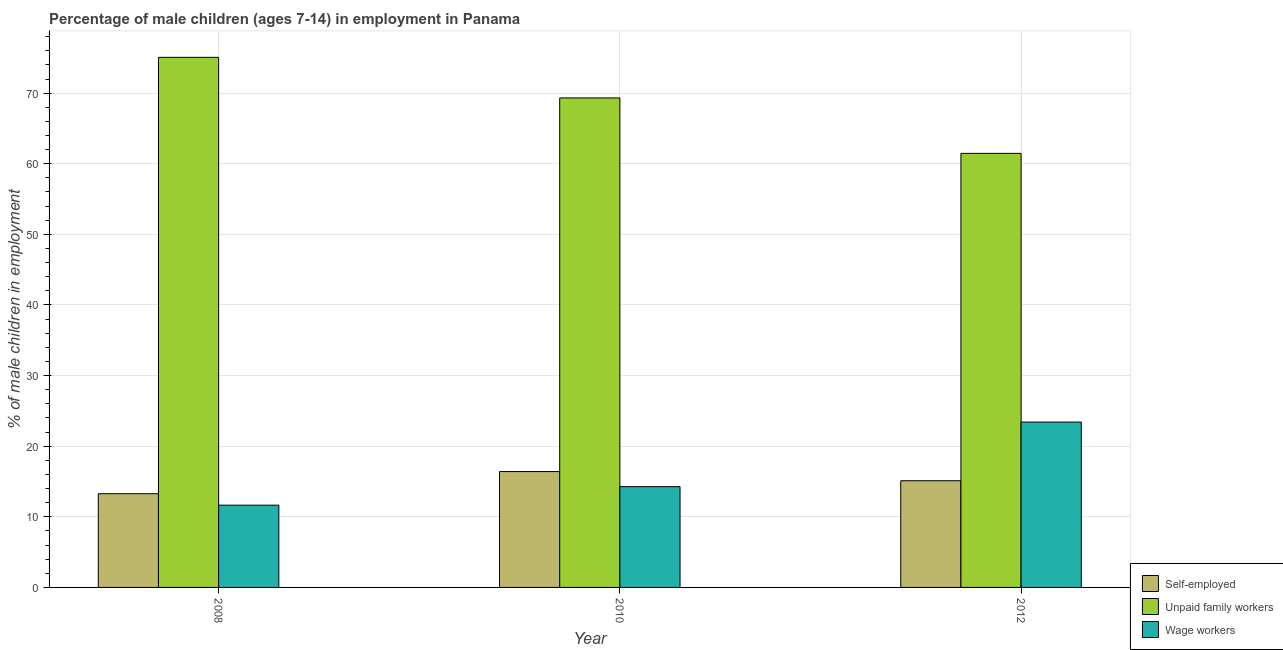How many groups of bars are there?
Offer a terse response. 3. How many bars are there on the 2nd tick from the left?
Give a very brief answer. 3. What is the percentage of self employed children in 2012?
Provide a succinct answer. 15.11. Across all years, what is the maximum percentage of children employed as unpaid family workers?
Offer a very short reply. 75.07. Across all years, what is the minimum percentage of children employed as wage workers?
Keep it short and to the point. 11.65. In which year was the percentage of children employed as unpaid family workers minimum?
Offer a terse response. 2012. What is the total percentage of children employed as unpaid family workers in the graph?
Your answer should be compact. 205.86. What is the difference between the percentage of self employed children in 2008 and that in 2010?
Provide a short and direct response. -3.14. What is the difference between the percentage of children employed as unpaid family workers in 2010 and the percentage of children employed as wage workers in 2008?
Make the answer very short. -5.75. What is the average percentage of children employed as wage workers per year?
Give a very brief answer. 16.45. What is the ratio of the percentage of children employed as wage workers in 2008 to that in 2010?
Provide a short and direct response. 0.82. Is the percentage of children employed as unpaid family workers in 2008 less than that in 2012?
Ensure brevity in your answer.  No. What is the difference between the highest and the second highest percentage of children employed as unpaid family workers?
Your response must be concise. 5.75. What is the difference between the highest and the lowest percentage of children employed as unpaid family workers?
Offer a terse response. 13.6. What does the 3rd bar from the left in 2008 represents?
Ensure brevity in your answer.  Wage workers. What does the 3rd bar from the right in 2008 represents?
Offer a terse response. Self-employed. Is it the case that in every year, the sum of the percentage of self employed children and percentage of children employed as unpaid family workers is greater than the percentage of children employed as wage workers?
Your response must be concise. Yes. How many bars are there?
Make the answer very short. 9. Are all the bars in the graph horizontal?
Provide a short and direct response. No. What is the difference between two consecutive major ticks on the Y-axis?
Offer a terse response. 10. Does the graph contain grids?
Give a very brief answer. Yes. How many legend labels are there?
Offer a very short reply. 3. What is the title of the graph?
Give a very brief answer. Percentage of male children (ages 7-14) in employment in Panama. Does "Machinery" appear as one of the legend labels in the graph?
Keep it short and to the point. No. What is the label or title of the X-axis?
Offer a terse response. Year. What is the label or title of the Y-axis?
Give a very brief answer. % of male children in employment. What is the % of male children in employment in Self-employed in 2008?
Your answer should be compact. 13.27. What is the % of male children in employment of Unpaid family workers in 2008?
Keep it short and to the point. 75.07. What is the % of male children in employment of Wage workers in 2008?
Provide a short and direct response. 11.65. What is the % of male children in employment in Self-employed in 2010?
Provide a succinct answer. 16.41. What is the % of male children in employment of Unpaid family workers in 2010?
Make the answer very short. 69.32. What is the % of male children in employment in Wage workers in 2010?
Provide a succinct answer. 14.27. What is the % of male children in employment in Self-employed in 2012?
Your answer should be compact. 15.11. What is the % of male children in employment in Unpaid family workers in 2012?
Ensure brevity in your answer.  61.47. What is the % of male children in employment in Wage workers in 2012?
Your answer should be compact. 23.42. Across all years, what is the maximum % of male children in employment in Self-employed?
Give a very brief answer. 16.41. Across all years, what is the maximum % of male children in employment of Unpaid family workers?
Your response must be concise. 75.07. Across all years, what is the maximum % of male children in employment in Wage workers?
Your response must be concise. 23.42. Across all years, what is the minimum % of male children in employment in Self-employed?
Provide a short and direct response. 13.27. Across all years, what is the minimum % of male children in employment of Unpaid family workers?
Offer a very short reply. 61.47. Across all years, what is the minimum % of male children in employment of Wage workers?
Your response must be concise. 11.65. What is the total % of male children in employment of Self-employed in the graph?
Keep it short and to the point. 44.79. What is the total % of male children in employment in Unpaid family workers in the graph?
Your response must be concise. 205.86. What is the total % of male children in employment of Wage workers in the graph?
Provide a succinct answer. 49.34. What is the difference between the % of male children in employment in Self-employed in 2008 and that in 2010?
Your answer should be very brief. -3.14. What is the difference between the % of male children in employment in Unpaid family workers in 2008 and that in 2010?
Give a very brief answer. 5.75. What is the difference between the % of male children in employment in Wage workers in 2008 and that in 2010?
Offer a very short reply. -2.62. What is the difference between the % of male children in employment in Self-employed in 2008 and that in 2012?
Provide a succinct answer. -1.84. What is the difference between the % of male children in employment in Wage workers in 2008 and that in 2012?
Ensure brevity in your answer.  -11.77. What is the difference between the % of male children in employment of Unpaid family workers in 2010 and that in 2012?
Offer a terse response. 7.85. What is the difference between the % of male children in employment in Wage workers in 2010 and that in 2012?
Your answer should be compact. -9.15. What is the difference between the % of male children in employment of Self-employed in 2008 and the % of male children in employment of Unpaid family workers in 2010?
Provide a succinct answer. -56.05. What is the difference between the % of male children in employment of Self-employed in 2008 and the % of male children in employment of Wage workers in 2010?
Your response must be concise. -1. What is the difference between the % of male children in employment of Unpaid family workers in 2008 and the % of male children in employment of Wage workers in 2010?
Keep it short and to the point. 60.8. What is the difference between the % of male children in employment in Self-employed in 2008 and the % of male children in employment in Unpaid family workers in 2012?
Your answer should be compact. -48.2. What is the difference between the % of male children in employment in Self-employed in 2008 and the % of male children in employment in Wage workers in 2012?
Ensure brevity in your answer.  -10.15. What is the difference between the % of male children in employment in Unpaid family workers in 2008 and the % of male children in employment in Wage workers in 2012?
Offer a very short reply. 51.65. What is the difference between the % of male children in employment in Self-employed in 2010 and the % of male children in employment in Unpaid family workers in 2012?
Make the answer very short. -45.06. What is the difference between the % of male children in employment in Self-employed in 2010 and the % of male children in employment in Wage workers in 2012?
Give a very brief answer. -7.01. What is the difference between the % of male children in employment in Unpaid family workers in 2010 and the % of male children in employment in Wage workers in 2012?
Provide a succinct answer. 45.9. What is the average % of male children in employment in Self-employed per year?
Give a very brief answer. 14.93. What is the average % of male children in employment of Unpaid family workers per year?
Provide a succinct answer. 68.62. What is the average % of male children in employment in Wage workers per year?
Offer a very short reply. 16.45. In the year 2008, what is the difference between the % of male children in employment of Self-employed and % of male children in employment of Unpaid family workers?
Ensure brevity in your answer.  -61.8. In the year 2008, what is the difference between the % of male children in employment in Self-employed and % of male children in employment in Wage workers?
Provide a succinct answer. 1.62. In the year 2008, what is the difference between the % of male children in employment of Unpaid family workers and % of male children in employment of Wage workers?
Ensure brevity in your answer.  63.42. In the year 2010, what is the difference between the % of male children in employment in Self-employed and % of male children in employment in Unpaid family workers?
Keep it short and to the point. -52.91. In the year 2010, what is the difference between the % of male children in employment of Self-employed and % of male children in employment of Wage workers?
Offer a very short reply. 2.14. In the year 2010, what is the difference between the % of male children in employment of Unpaid family workers and % of male children in employment of Wage workers?
Keep it short and to the point. 55.05. In the year 2012, what is the difference between the % of male children in employment of Self-employed and % of male children in employment of Unpaid family workers?
Your answer should be very brief. -46.36. In the year 2012, what is the difference between the % of male children in employment of Self-employed and % of male children in employment of Wage workers?
Your answer should be very brief. -8.31. In the year 2012, what is the difference between the % of male children in employment of Unpaid family workers and % of male children in employment of Wage workers?
Your answer should be very brief. 38.05. What is the ratio of the % of male children in employment in Self-employed in 2008 to that in 2010?
Make the answer very short. 0.81. What is the ratio of the % of male children in employment of Unpaid family workers in 2008 to that in 2010?
Ensure brevity in your answer.  1.08. What is the ratio of the % of male children in employment in Wage workers in 2008 to that in 2010?
Offer a very short reply. 0.82. What is the ratio of the % of male children in employment of Self-employed in 2008 to that in 2012?
Provide a succinct answer. 0.88. What is the ratio of the % of male children in employment of Unpaid family workers in 2008 to that in 2012?
Provide a short and direct response. 1.22. What is the ratio of the % of male children in employment of Wage workers in 2008 to that in 2012?
Offer a terse response. 0.5. What is the ratio of the % of male children in employment in Self-employed in 2010 to that in 2012?
Give a very brief answer. 1.09. What is the ratio of the % of male children in employment in Unpaid family workers in 2010 to that in 2012?
Offer a very short reply. 1.13. What is the ratio of the % of male children in employment in Wage workers in 2010 to that in 2012?
Give a very brief answer. 0.61. What is the difference between the highest and the second highest % of male children in employment of Unpaid family workers?
Your answer should be compact. 5.75. What is the difference between the highest and the second highest % of male children in employment in Wage workers?
Your response must be concise. 9.15. What is the difference between the highest and the lowest % of male children in employment in Self-employed?
Ensure brevity in your answer.  3.14. What is the difference between the highest and the lowest % of male children in employment of Wage workers?
Give a very brief answer. 11.77. 